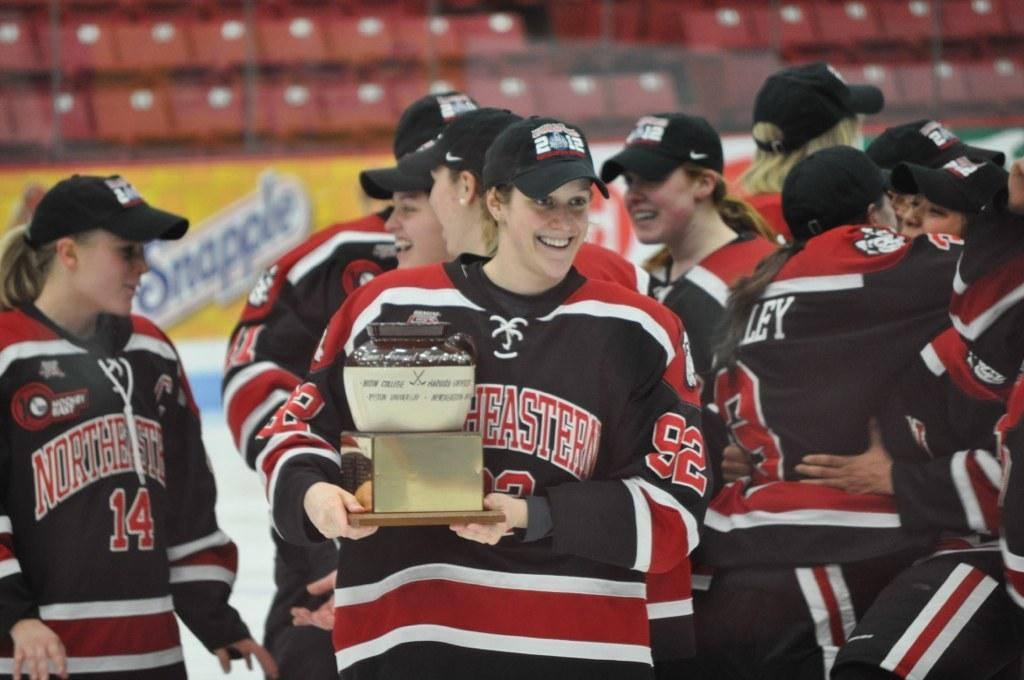<image>
Render a clear and concise summary of the photo. Players from Northeastern holding a trophy and wearing 2012 caps. 